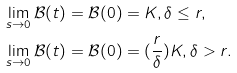Convert formula to latex. <formula><loc_0><loc_0><loc_500><loc_500>\lim _ { s \rightarrow 0 } \mathcal { B } ( t ) & = \mathcal { B } ( 0 ) = K , \delta \leq r , \\ \lim _ { s \rightarrow 0 } \mathcal { B } ( t ) & = \mathcal { B } ( 0 ) = ( \frac { r } { \delta } ) K , \delta > r .</formula> 